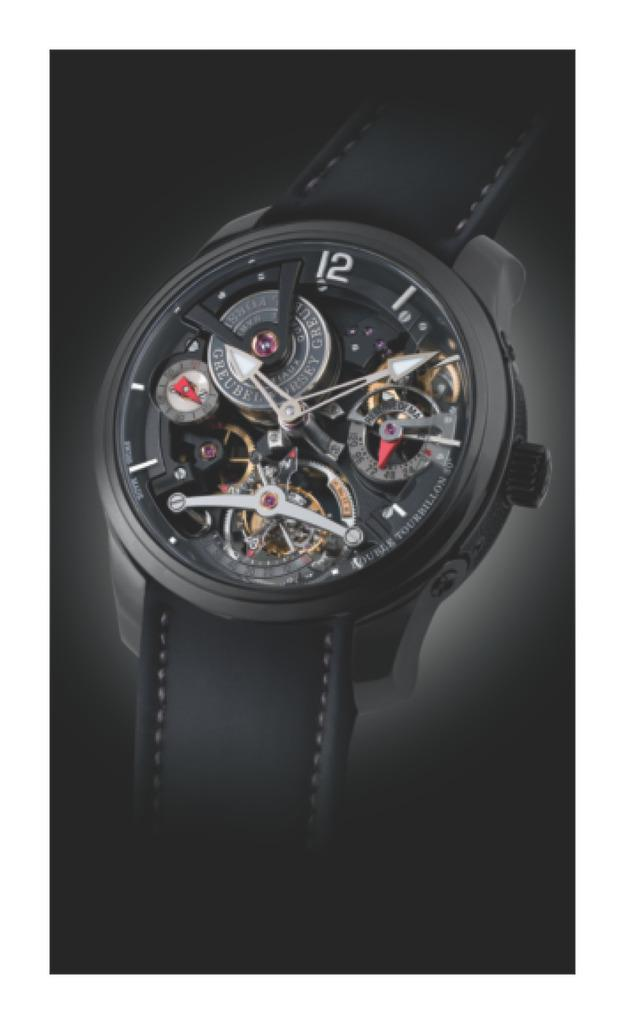<image>
Create a compact narrative representing the image presented. A black Greubel watch with a clear face so you can see the inner workings. 